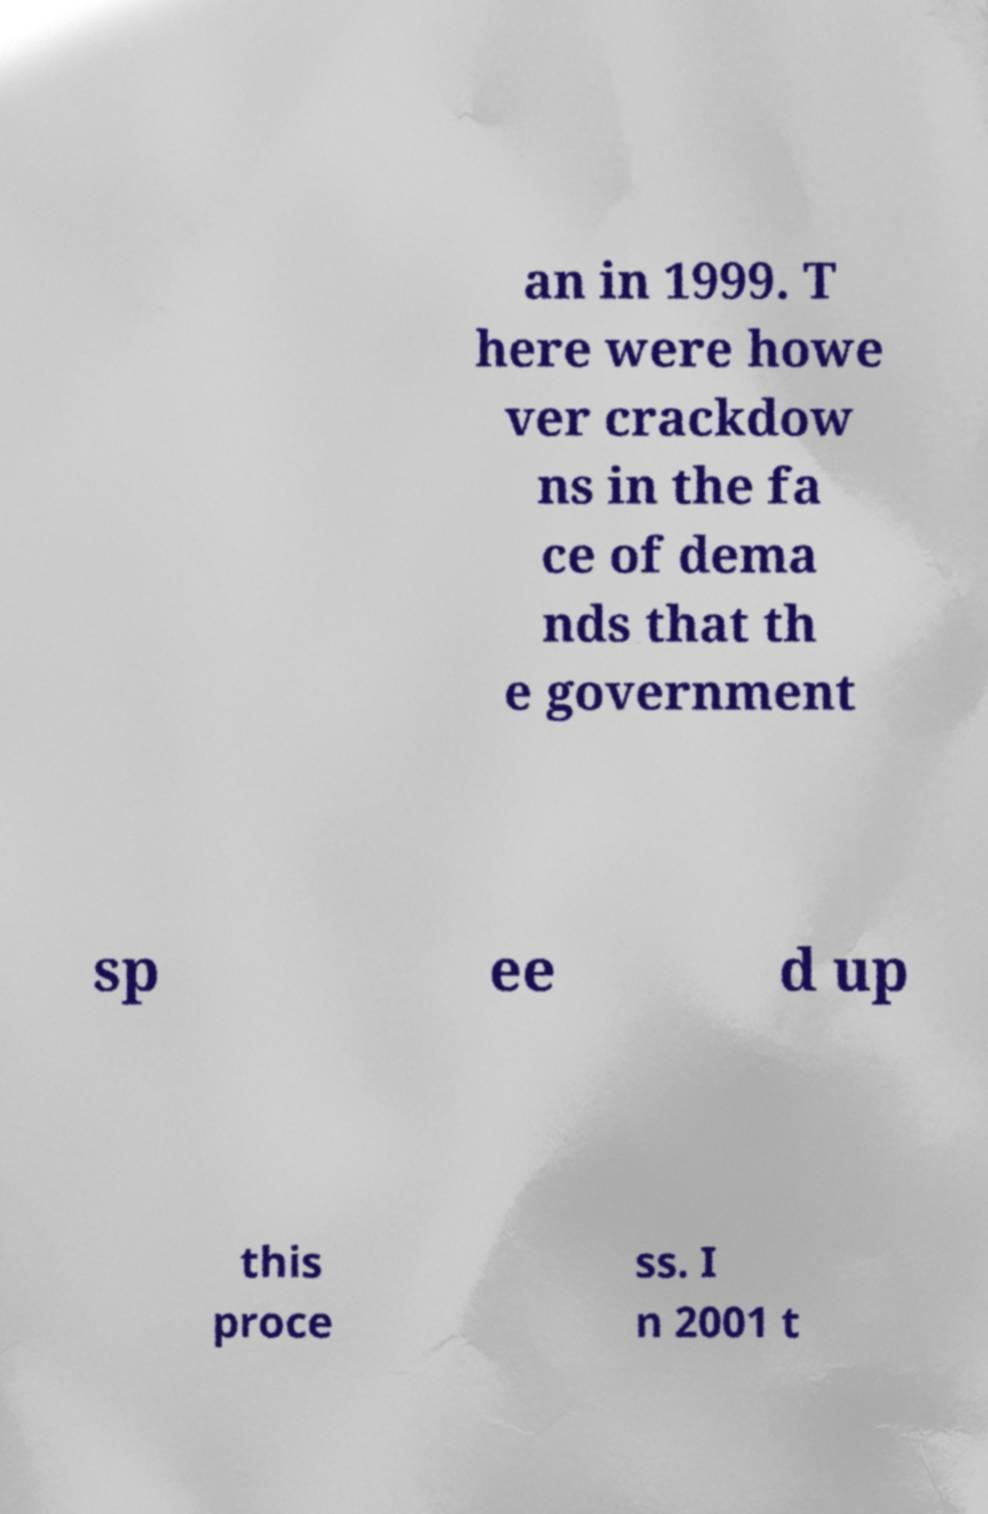There's text embedded in this image that I need extracted. Can you transcribe it verbatim? an in 1999. T here were howe ver crackdow ns in the fa ce of dema nds that th e government sp ee d up this proce ss. I n 2001 t 